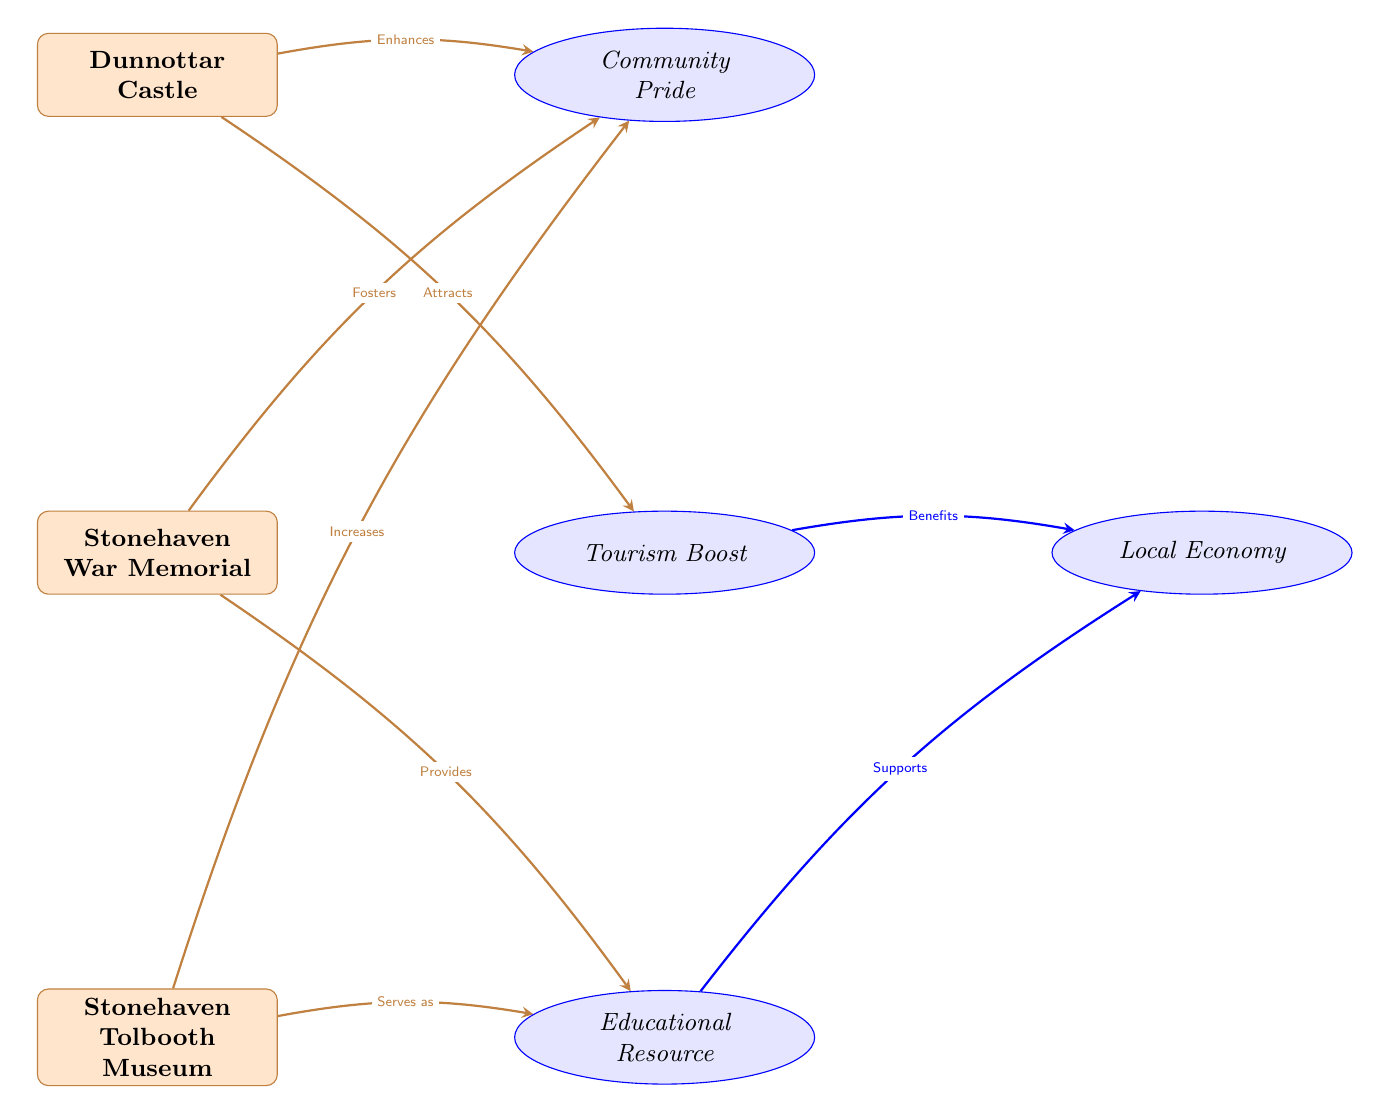What historical site is at the top of the diagram? The diagram indicates that Dunnottar Castle is located at the top, making it the first historical site listed.
Answer: Dunnottar Castle How many historical sites are shown in the diagram? The diagram displays three historical sites: Dunnottar Castle, Stonehaven War Memorial, and Stonehaven Tolbooth Museum. By counting these nodes, it is clear that there are three sites.
Answer: 3 Which impact is directly linked to Stonehaven War Memorial? The diagram shows that Stonehaven War Memorial directly fosters Community Pride and provides an Educational Resource, indicating two impacts. Since the question asks for one, either one qualifies, but Community Pride is mentioned first.
Answer: Community Pride What type of relationship does Dunnottar Castle have with Tourism Boost? The relationship is described as "Attracts," indicating that Dunnottar Castle brings people to Stonehaven, enhancing tourism. This is a direct influence from the historical site to the social impact.
Answer: Attracts Which historical site has multiple social impacts associated with it? Stonehaven Tolbooth Museum is linked to two impacts: it serves as an Educational Resource and increases Community Pride, indicating its multifaceted role in society.
Answer: Stonehaven Tolbooth Museum What benefits does Tourism Boost provide according to the diagram? The diagram states that Tourism Boost benefits the Local Economy, indicating a positive economic impact linked to increased visitor numbers.
Answer: Local Economy What is the connection between educational resources and the local economy? The diagram highlights that an Educational Resource supports the Local Economy, illustrating how educational offerings can stimulate economic growth.
Answer: Supports How does Dunnottar Castle influence Community Pride? The diagram specifies that Dunnottar Castle enhances Community Pride, signifying that its presence fosters a sense of belonging and pride among residents.
Answer: Enhances 